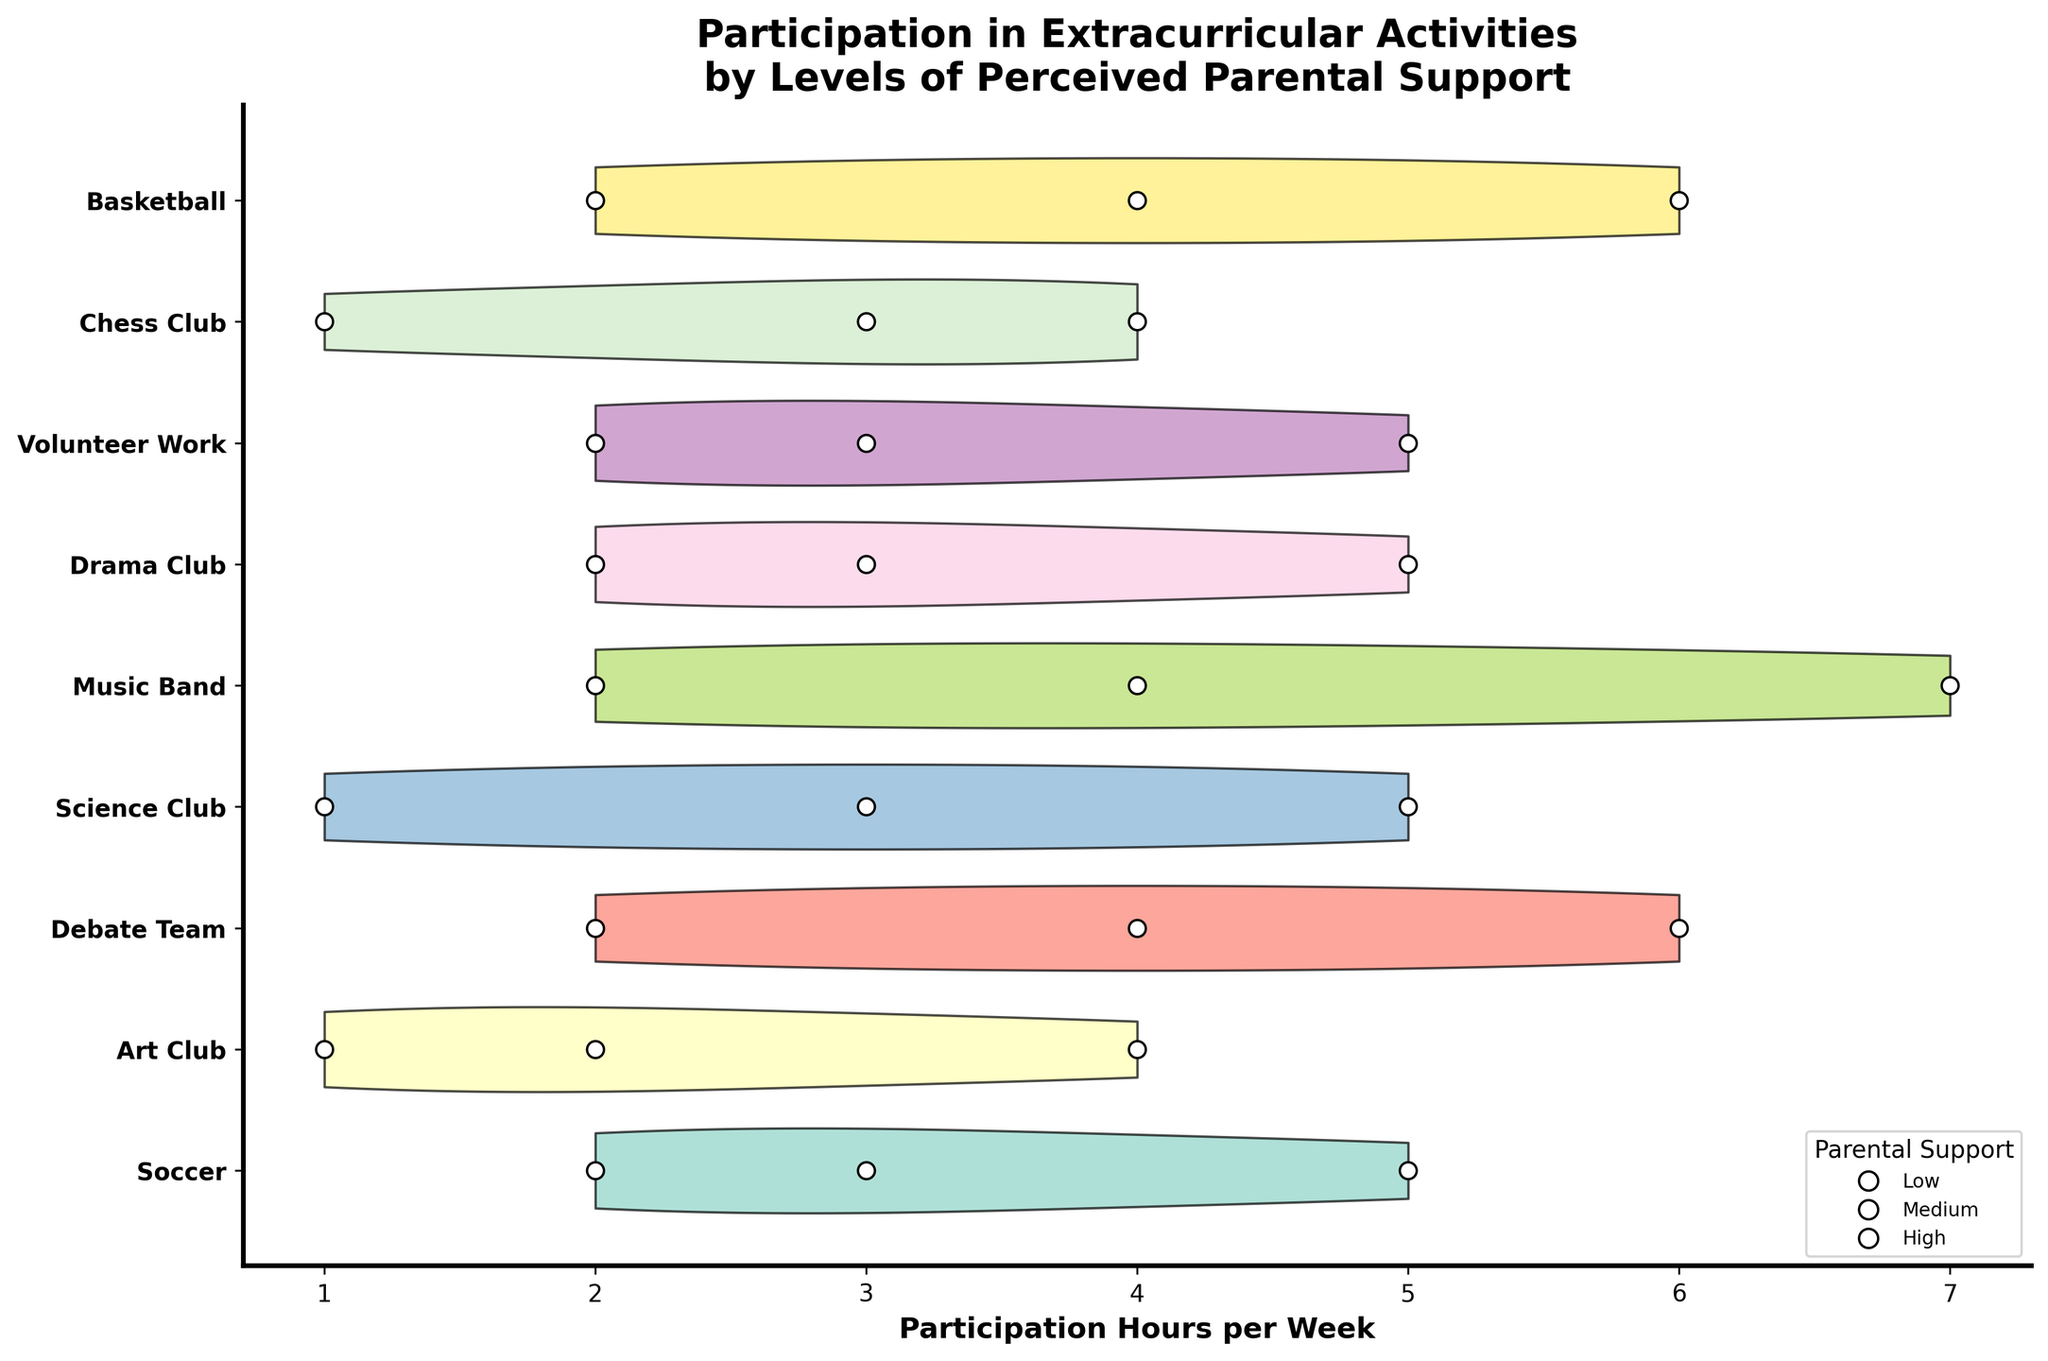What is the title of the figure? The title of the figure is displayed at the top and provides a summary of what the plot is about, which in this case is related to extracurricular activities and perceived parental support.
Answer: Participation in Extracurricular Activities by Levels of Perceived Parental Support Which activity shows the highest participation hours for students with high perceived parental support? To determine this, we look at the farthest filled in violin plot (to the right) for high support, observed as the darker shades. Music Band shows the highest value.
Answer: Music Band Which activity has the lowest median participation hours for students with low perceived parental support? For each activity, find the median value among low support participants marked by the scatter plots with three values (white dots). Science Club and Art Club both show the lowest median.
Answer: Science Club & Art Club What is the average participation hours for students with medium perceived parental support in the Drama Club? To calculate this, identify the white scatter plot points within the Drama Club’s violin that represent medium support and compute the mean. Here, the points are at 3 hours.
Answer: 3 Compare the participation hours in the Soccer and Chess Club for those with low and high parental support. Which activity has a larger difference? Calculate the difference between low and high values within each activity. Soccer: 2 (low) to 5 (high), difference = 3. Chess Club: 1 (low) to 4 (high), difference = 3. Equal for both.
Answer: Equal Considering all activities, which one shows the least variation in participation hours? The least variation can be found by looking at the narrowest violin plot which shows the smallest spread. This is seen in Art Club.
Answer: Art Club Which activity shows a higher participation hour for medium parental support compared to low parental support by the highest margin? Calculate the differences between medium and low for each activity. Highest margin can be seen where middle scatter plot point is significantly higher. Drama Club (3-2=1) has a notable margin.
Answer: Drama Club How do the participation hours in Debate Team for students with low parental support compare to those with high parental support? Look at the two ends of the participation range for low and high support within Debate Team. Low at 2 hours; high at 6 hours.
Answer: Higher for high parental support Which activity shows overlapping ranges between medium and high parental support participation hours? An overlapping range is observed in the violin plots where the medium and high spectrums of the violin intersect. Soccer and Debate Team show overlaps.
Answer: Soccer & Debate Team How does perceived parental support affect participation hours across all activities in general? Examine the overall trend; higher perceived support generally correlates with higher participation across most activities.
Answer: Higher support -> higher participation 